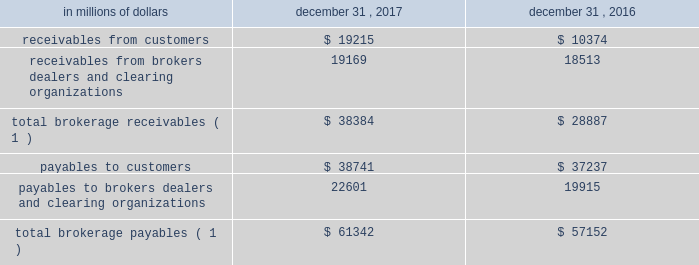12 .
Brokerage receivables and brokerage payables citi has receivables and payables for financial instruments sold to and purchased from brokers , dealers and customers , which arise in the ordinary course of business .
Citi is exposed to risk of loss from the inability of brokers , dealers or customers to pay for purchases or to deliver the financial instruments sold , in which case citi would have to sell or purchase the financial instruments at prevailing market prices .
Credit risk is reduced to the extent that an exchange or clearing organization acts as a counterparty to the transaction and replaces the broker , dealer or customer in question .
Citi seeks to protect itself from the risks associated with customer activities by requiring customers to maintain margin collateral in compliance with regulatory and internal guidelines .
Margin levels are monitored daily , and customers deposit additional collateral as required .
Where customers cannot meet collateral requirements , citi may liquidate sufficient underlying financial instruments to bring the customer into compliance with the required margin level .
Exposure to credit risk is impacted by market volatility , which may impair the ability of clients to satisfy their obligations to citi .
Credit limits are established and closely monitored for customers and for brokers and dealers engaged in forwards , futures and other transactions deemed to be credit sensitive .
Brokerage receivables and brokerage payables consisted of the following: .
Payables to brokers , dealers and clearing organizations 22601 19915 total brokerage payables ( 1 ) $ 61342 $ 57152 ( 1 ) includes brokerage receivables and payables recorded by citi broker- dealer entities that are accounted for in accordance with the aicpa accounting guide for brokers and dealers in securities as codified in asc 940-320. .
At december 312017 what was the ratio of the total brokerage receivables to the total brokerage payables? 
Rationale: at december 312017 there was $ 0.63 of total brokerage receivables for every $ 1 of total brokerage payables
Computations: (38384 / 61342)
Answer: 0.62574. 